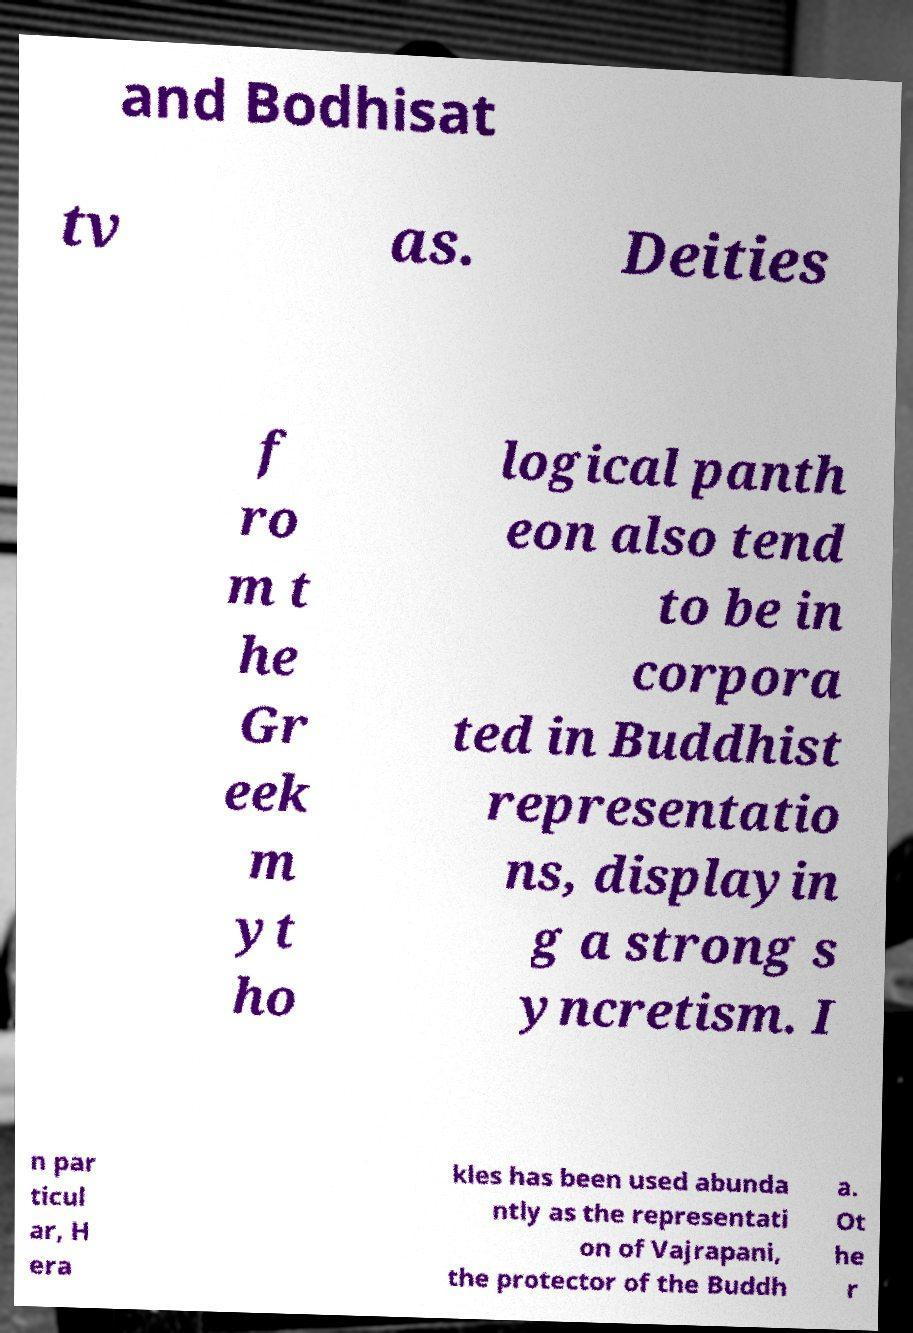There's text embedded in this image that I need extracted. Can you transcribe it verbatim? and Bodhisat tv as. Deities f ro m t he Gr eek m yt ho logical panth eon also tend to be in corpora ted in Buddhist representatio ns, displayin g a strong s yncretism. I n par ticul ar, H era kles has been used abunda ntly as the representati on of Vajrapani, the protector of the Buddh a. Ot he r 